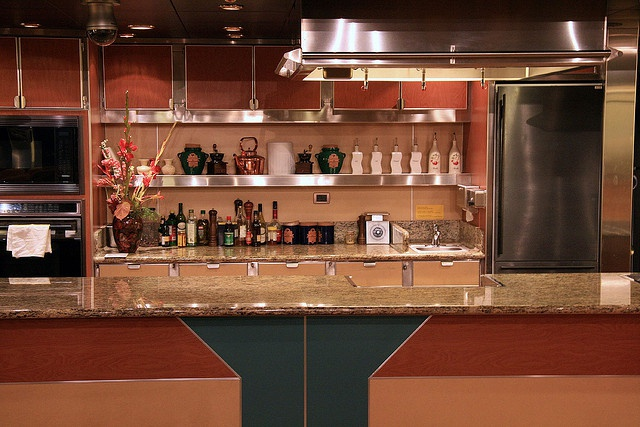Describe the objects in this image and their specific colors. I can see refrigerator in black, maroon, and gray tones, oven in black, lightgray, gray, and maroon tones, microwave in black, gray, and maroon tones, bottle in black, tan, brown, and maroon tones, and vase in black, maroon, and brown tones in this image. 